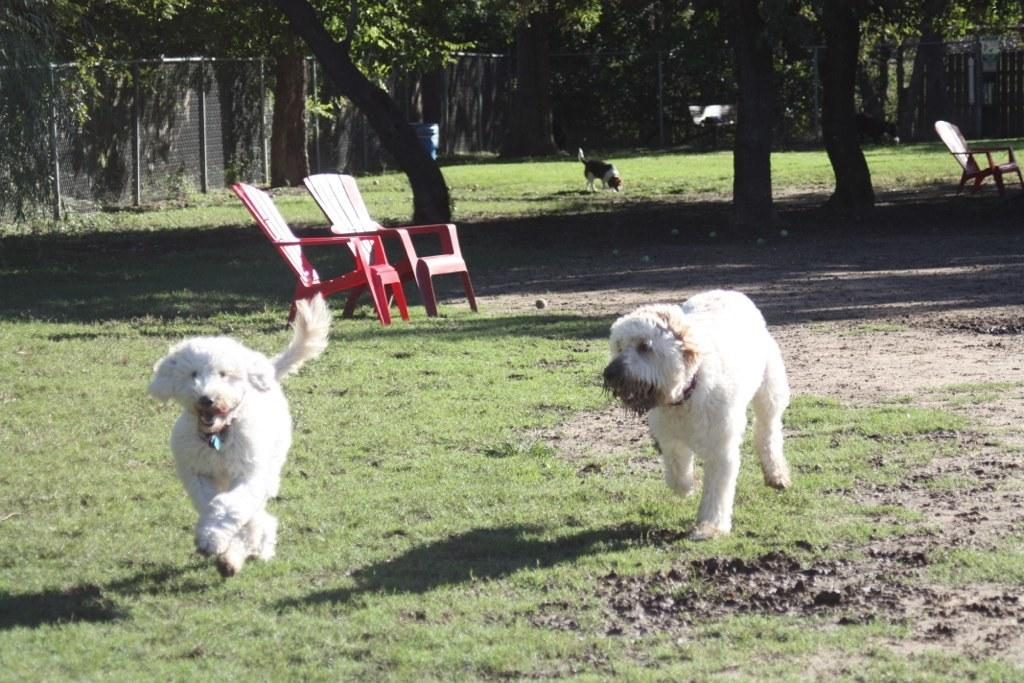How many dogs are visible in the image? There are two dogs in the image. What are the dogs doing in the image? The dogs are running on grass. What can be seen in the background of the image? There are two chairs, a third dog, a tree, and a fence in the background of the image. Is there any furniture present in the image? Yes, there is a chair in the image. What shape is the dog in the image? Dogs are not described by shapes, as they are living beings with specific physical features. The question is not applicable to the image. 